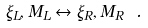<formula> <loc_0><loc_0><loc_500><loc_500>\xi _ { L } , M _ { L } \leftrightarrow \xi _ { R } , M _ { R } \ .</formula> 